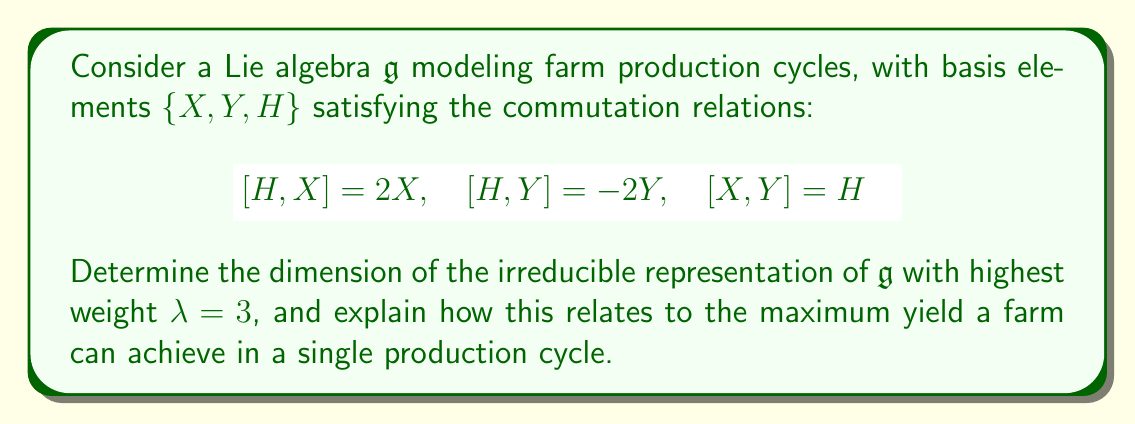Could you help me with this problem? 1) First, recognize that this Lie algebra $\mathfrak{g}$ is isomorphic to $\mathfrak{sl}(2,\mathbb{C})$, the special linear algebra of 2x2 complex matrices with trace zero.

2) For $\mathfrak{sl}(2,\mathbb{C})$, the irreducible representations are parameterized by non-negative integers (highest weights). The dimension of the irreducible representation with highest weight $\lambda$ is given by $\lambda + 1$.

3) In this case, $\lambda = 3$, so the dimension of the irreducible representation is $3 + 1 = 4$.

4) Interpreting this in the context of farm production:
   - $H$ could represent the balance between resources and output
   - $X$ could represent increasing production
   - $Y$ could represent resource depletion

5) The 4-dimensional representation suggests that there are four distinct states in the production cycle, which could be interpreted as:
   - Fallow (resting)
   - Planting
   - Growing
   - Harvesting

6) The highest weight $\lambda = 3$ corresponds to the maximum yield state (harvesting), while the other dimensions represent the other necessary stages in the cycle.

7) This model suggests that to achieve maximum yield, a farm must go through all four stages, and cannot skip any stage to reach the maximum yield faster.
Answer: 4-dimensional irreducible representation 